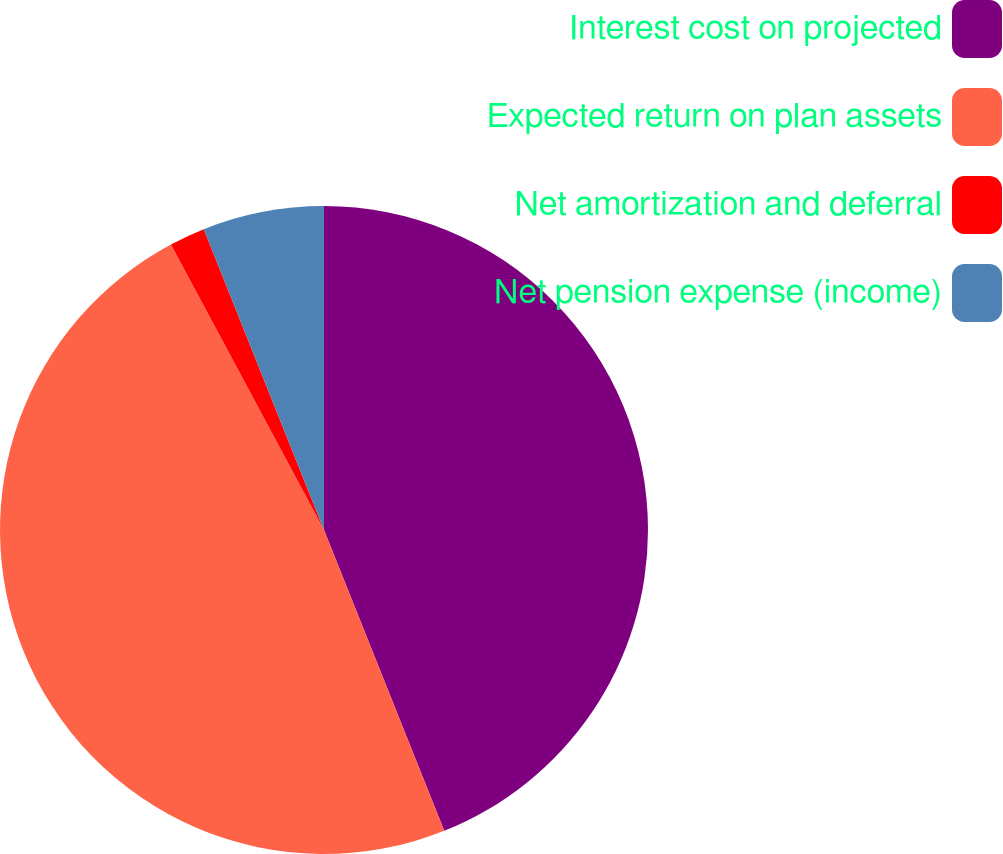Convert chart to OTSL. <chart><loc_0><loc_0><loc_500><loc_500><pie_chart><fcel>Interest cost on projected<fcel>Expected return on plan assets<fcel>Net amortization and deferral<fcel>Net pension expense (income)<nl><fcel>43.95%<fcel>48.22%<fcel>1.78%<fcel>6.05%<nl></chart> 